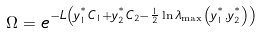Convert formula to latex. <formula><loc_0><loc_0><loc_500><loc_500>\Omega = e ^ { - L \left ( y _ { 1 } ^ { ^ { * } } C _ { 1 } + y _ { 2 } ^ { ^ { * } } C _ { 2 } - \frac { 1 } { 2 } \ln \lambda _ { \max } \left ( y _ { 1 } ^ { ^ { * } } , y _ { 2 } ^ { ^ { * } } \right ) \right ) }</formula> 